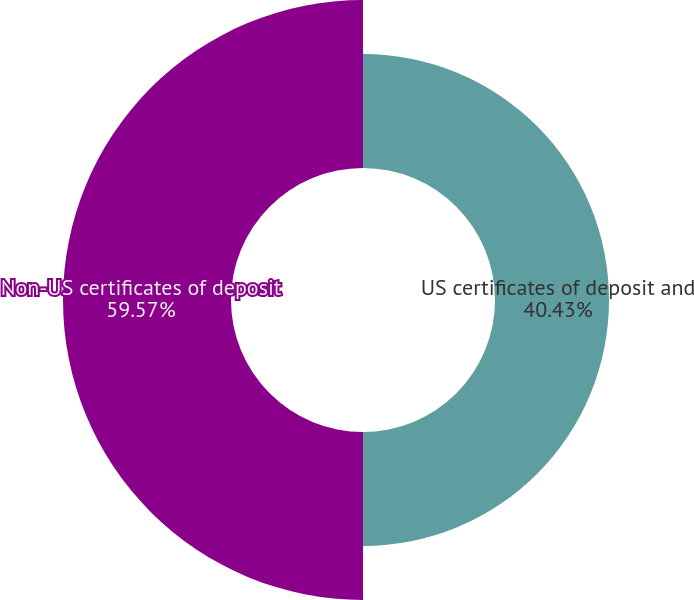Convert chart to OTSL. <chart><loc_0><loc_0><loc_500><loc_500><pie_chart><fcel>US certificates of deposit and<fcel>Non-US certificates of deposit<nl><fcel>40.43%<fcel>59.57%<nl></chart> 